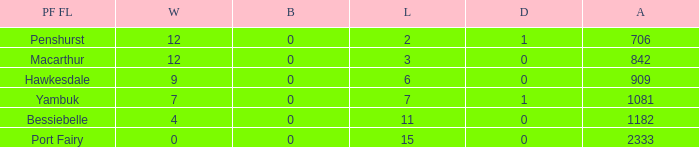How many byes when the draws are less than 0? 0.0. 